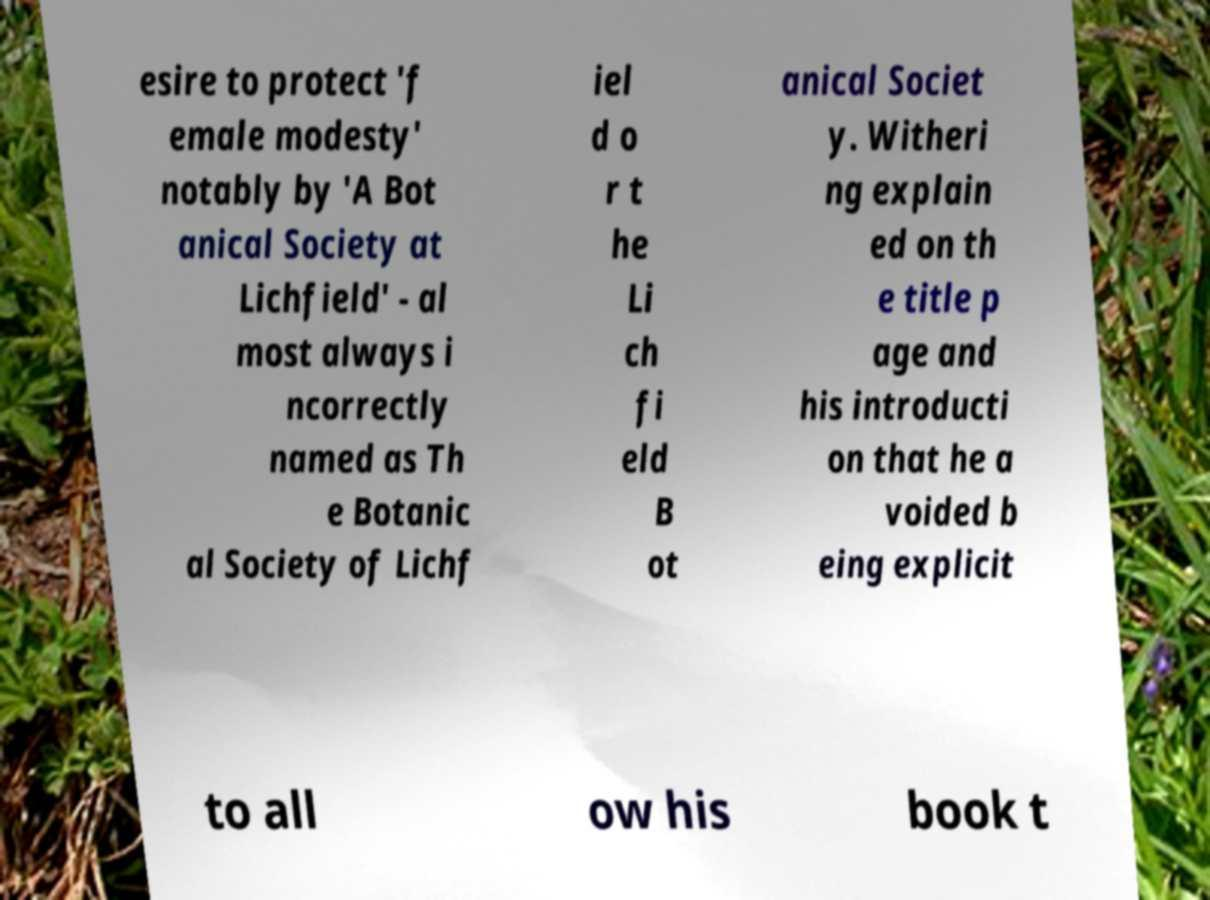There's text embedded in this image that I need extracted. Can you transcribe it verbatim? esire to protect 'f emale modesty' notably by 'A Bot anical Society at Lichfield' - al most always i ncorrectly named as Th e Botanic al Society of Lichf iel d o r t he Li ch fi eld B ot anical Societ y. Witheri ng explain ed on th e title p age and his introducti on that he a voided b eing explicit to all ow his book t 